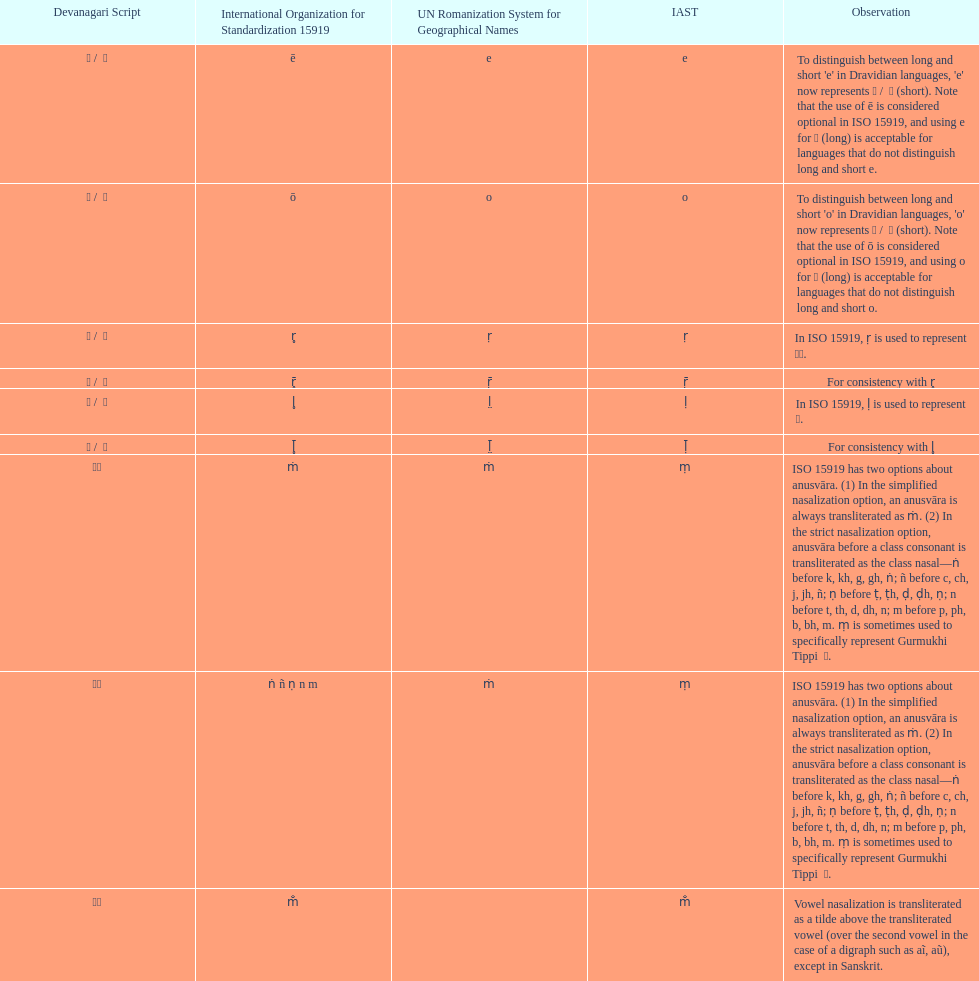Which devanagari transliteration is listed on the top of the table? ए / े. 